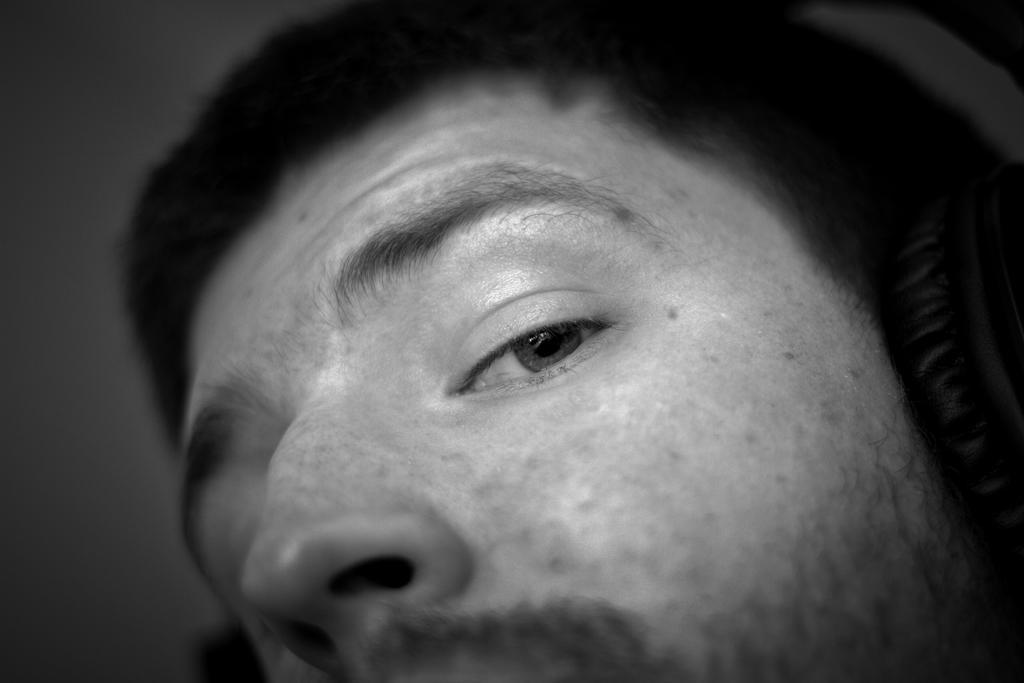Please provide a concise description of this image. This is a black and white image. We can see a person's face. And he is wearing a headset. 